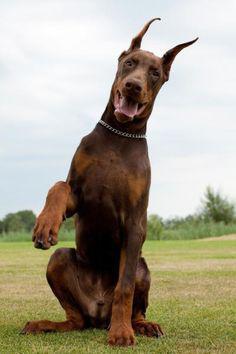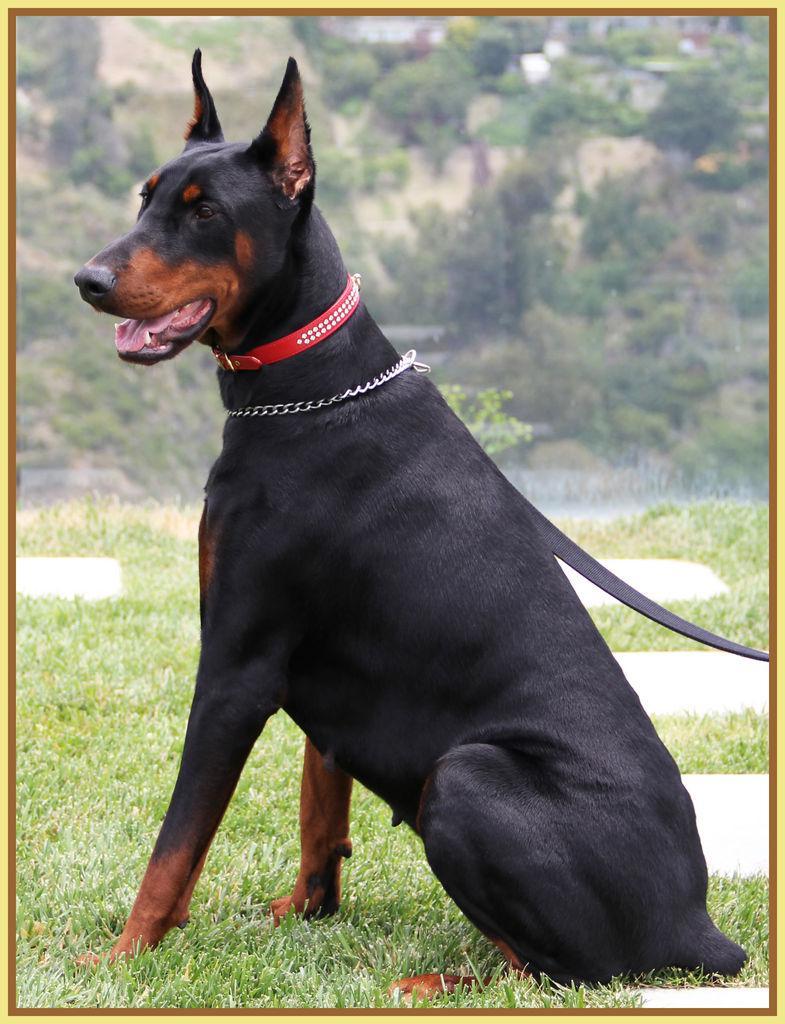The first image is the image on the left, the second image is the image on the right. Examine the images to the left and right. Is the description "A dog has one paw off the ground." accurate? Answer yes or no. Yes. The first image is the image on the left, the second image is the image on the right. Given the left and right images, does the statement "One image contains a doberman sitting upright with its body turned leftward, and the other image features a doberman sitting upright with one front paw raised." hold true? Answer yes or no. Yes. 